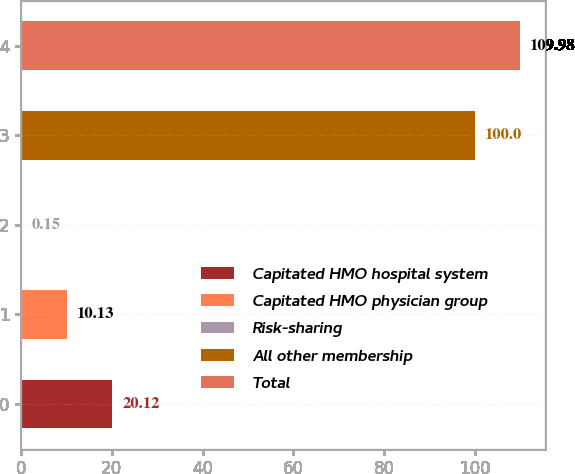Convert chart. <chart><loc_0><loc_0><loc_500><loc_500><bar_chart><fcel>Capitated HMO hospital system<fcel>Capitated HMO physician group<fcel>Risk-sharing<fcel>All other membership<fcel>Total<nl><fcel>20.12<fcel>10.13<fcel>0.15<fcel>100<fcel>109.98<nl></chart> 